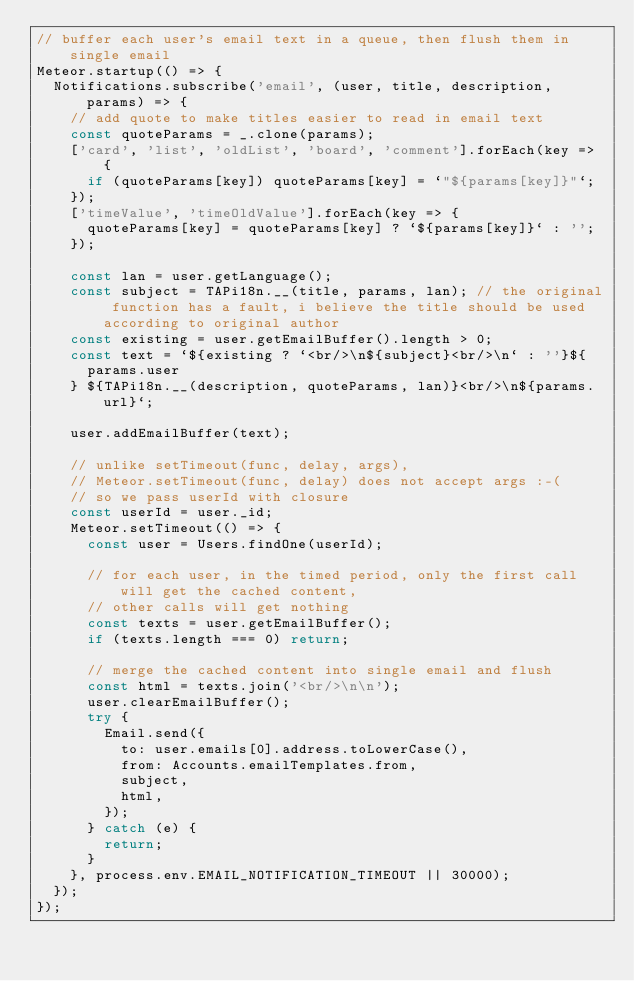Convert code to text. <code><loc_0><loc_0><loc_500><loc_500><_JavaScript_>// buffer each user's email text in a queue, then flush them in single email
Meteor.startup(() => {
  Notifications.subscribe('email', (user, title, description, params) => {
    // add quote to make titles easier to read in email text
    const quoteParams = _.clone(params);
    ['card', 'list', 'oldList', 'board', 'comment'].forEach(key => {
      if (quoteParams[key]) quoteParams[key] = `"${params[key]}"`;
    });
    ['timeValue', 'timeOldValue'].forEach(key => {
      quoteParams[key] = quoteParams[key] ? `${params[key]}` : '';
    });

    const lan = user.getLanguage();
    const subject = TAPi18n.__(title, params, lan); // the original function has a fault, i believe the title should be used according to original author
    const existing = user.getEmailBuffer().length > 0;
    const text = `${existing ? `<br/>\n${subject}<br/>\n` : ''}${
      params.user
    } ${TAPi18n.__(description, quoteParams, lan)}<br/>\n${params.url}`;

    user.addEmailBuffer(text);

    // unlike setTimeout(func, delay, args),
    // Meteor.setTimeout(func, delay) does not accept args :-(
    // so we pass userId with closure
    const userId = user._id;
    Meteor.setTimeout(() => {
      const user = Users.findOne(userId);

      // for each user, in the timed period, only the first call will get the cached content,
      // other calls will get nothing
      const texts = user.getEmailBuffer();
      if (texts.length === 0) return;

      // merge the cached content into single email and flush
      const html = texts.join('<br/>\n\n');
      user.clearEmailBuffer();
      try {
        Email.send({
          to: user.emails[0].address.toLowerCase(),
          from: Accounts.emailTemplates.from,
          subject,
          html,
        });
      } catch (e) {
        return;
      }
    }, process.env.EMAIL_NOTIFICATION_TIMEOUT || 30000);
  });
});
</code> 